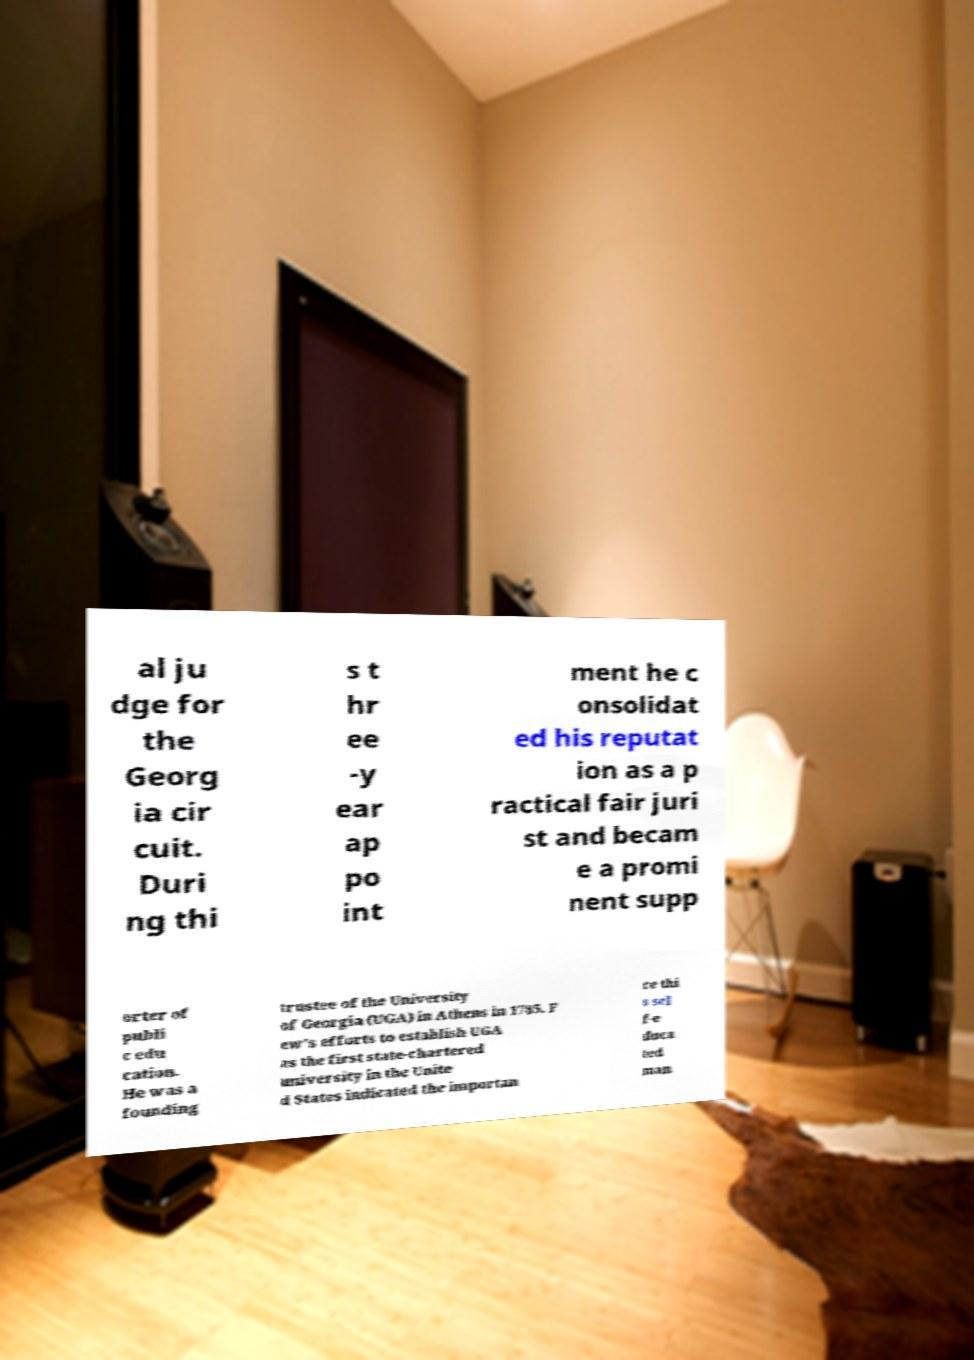There's text embedded in this image that I need extracted. Can you transcribe it verbatim? al ju dge for the Georg ia cir cuit. Duri ng thi s t hr ee -y ear ap po int ment he c onsolidat ed his reputat ion as a p ractical fair juri st and becam e a promi nent supp orter of publi c edu cation. He was a founding trustee of the University of Georgia (UGA) in Athens in 1785. F ew's efforts to establish UGA as the first state-chartered university in the Unite d States indicated the importan ce thi s sel f-e duca ted man 